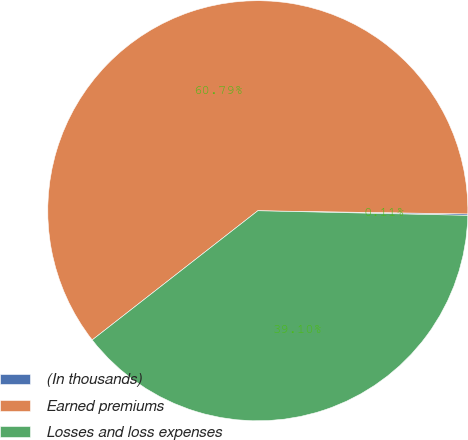<chart> <loc_0><loc_0><loc_500><loc_500><pie_chart><fcel>(In thousands)<fcel>Earned premiums<fcel>Losses and loss expenses<nl><fcel>0.11%<fcel>60.78%<fcel>39.1%<nl></chart> 